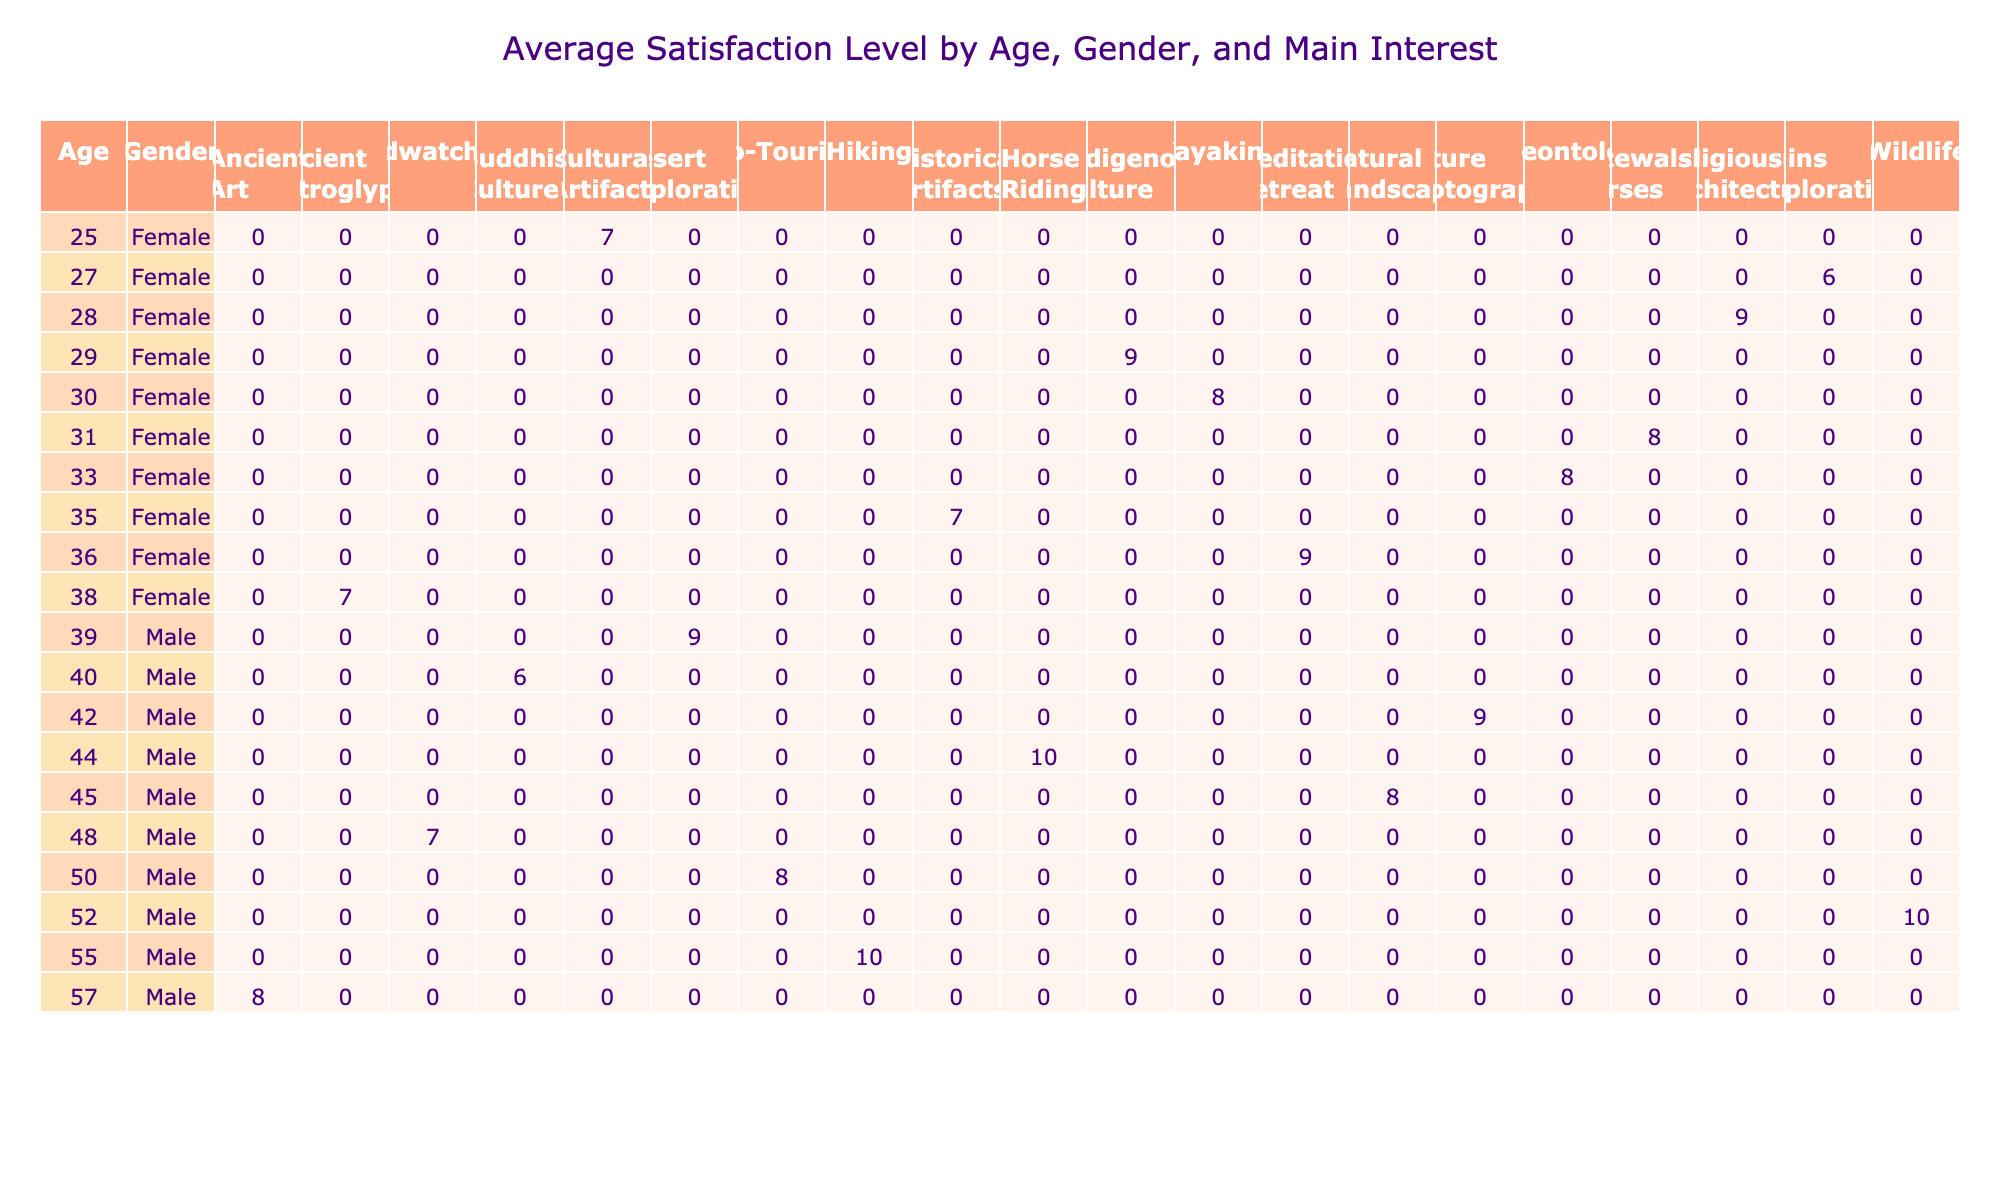What is the highest satisfaction level recorded among female visitors aged 30 years? Looking at the table, we find female visitors aged 30. The maximum satisfaction level for this age group is 8, derived from the 30-year-old Mongolian visitor to Terkhiin Tsagaan Lake.
Answer: 8 Which age group of male visitors shows the highest average satisfaction level for eco-tourism? There is one male visitor interested in eco-tourism at the age of 50 visiting Gun-Galuut Nature Reserve with a satisfaction level of 8. Since there are no other male visitors in this category, the average is simply the recorded value of 8.
Answer: 8 How many visitors from different nationalities expressed a satisfaction level of 7 or lower? To answer this, we count visitors with satisfaction levels 7 or below: Japanese (7), Chinese (6), Italian (6), French (7), and Brazilian (7). That's a total of 5 visitors.
Answer: 5 Is there any nationality where visitors have an interest in Buddhist culture? Upon examining the table, there is one visitor from China who expressed interest in Buddhist culture while visiting Amarbayasgalant Monastery, with a satisfaction level of 6. Therefore, the answer is yes.
Answer: Yes What is the average satisfaction level for female visitors interested in historical artifacts? From the table, only one female visitor, aged 35 from Japan, expressed interest in historical artifacts, with a satisfaction level of 7. As there's only one data point, the average is the same as that value, which is 7.
Answer: 7 Which mode of transportation is most commonly used by visitors interested in nature photography? Analyzing the table, we identify that only one visitor interested in nature photography is from Canada and used a car, achieving a satisfaction level of 9. With only one data point, the mode is car.
Answer: Car What is the difference between the highest and lowest satisfaction levels related to wildlife interest? Reviewing the table, the highest satisfaction level for wildlife (male visitor at 52 years) is 10 and the lowest (there are no other entries) is 10. Consequently, the difference is 10 - 10 = 0.
Answer: 0 What is the total satisfaction score of visitors who are Mongolian? Scanning the entries, we find three Mongolian visitors with respective satisfaction levels of 9, 8, and 10. Summing these: 9 + 8 + 10 gives a total satisfaction score of 27.
Answer: 27 